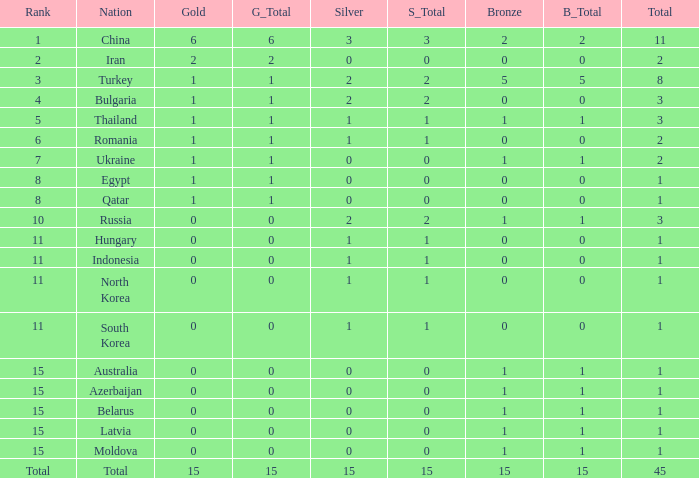What is the sum of the bronze medals of the nation with less than 0 silvers? None. Parse the table in full. {'header': ['Rank', 'Nation', 'Gold', 'G_Total', 'Silver', 'S_Total', 'Bronze', 'B_Total', 'Total'], 'rows': [['1', 'China', '6', '6', '3', '3', '2', '2', '11'], ['2', 'Iran', '2', '2', '0', '0', '0', '0', '2'], ['3', 'Turkey', '1', '1', '2', '2', '5', '5', '8'], ['4', 'Bulgaria', '1', '1', '2', '2', '0', '0', '3'], ['5', 'Thailand', '1', '1', '1', '1', '1', '1', '3'], ['6', 'Romania', '1', '1', '1', '1', '0', '0', '2'], ['7', 'Ukraine', '1', '1', '0', '0', '1', '1', '2'], ['8', 'Egypt', '1', '1', '0', '0', '0', '0', '1'], ['8', 'Qatar', '1', '1', '0', '0', '0', '0', '1'], ['10', 'Russia', '0', '0', '2', '2', '1', '1', '3'], ['11', 'Hungary', '0', '0', '1', '1', '0', '0', '1'], ['11', 'Indonesia', '0', '0', '1', '1', '0', '0', '1'], ['11', 'North Korea', '0', '0', '1', '1', '0', '0', '1'], ['11', 'South Korea', '0', '0', '1', '1', '0', '0', '1'], ['15', 'Australia', '0', '0', '0', '0', '1', '1', '1'], ['15', 'Azerbaijan', '0', '0', '0', '0', '1', '1', '1'], ['15', 'Belarus', '0', '0', '0', '0', '1', '1', '1'], ['15', 'Latvia', '0', '0', '0', '0', '1', '1', '1'], ['15', 'Moldova', '0', '0', '0', '0', '1', '1', '1'], ['Total', 'Total', '15', '15', '15', '15', '15', '15', '45']]} 